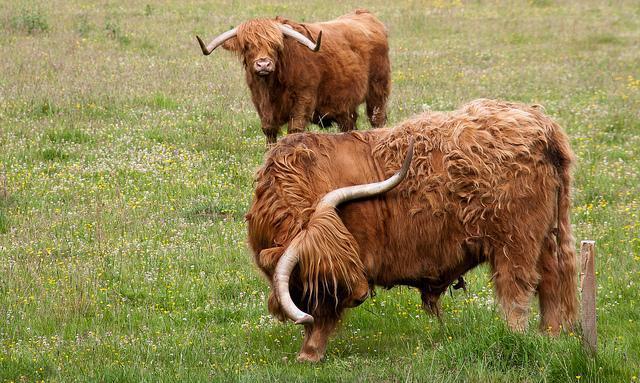How many are they?
Give a very brief answer. 2. How many horns are there?
Give a very brief answer. 4. How many cows are there?
Give a very brief answer. 2. 